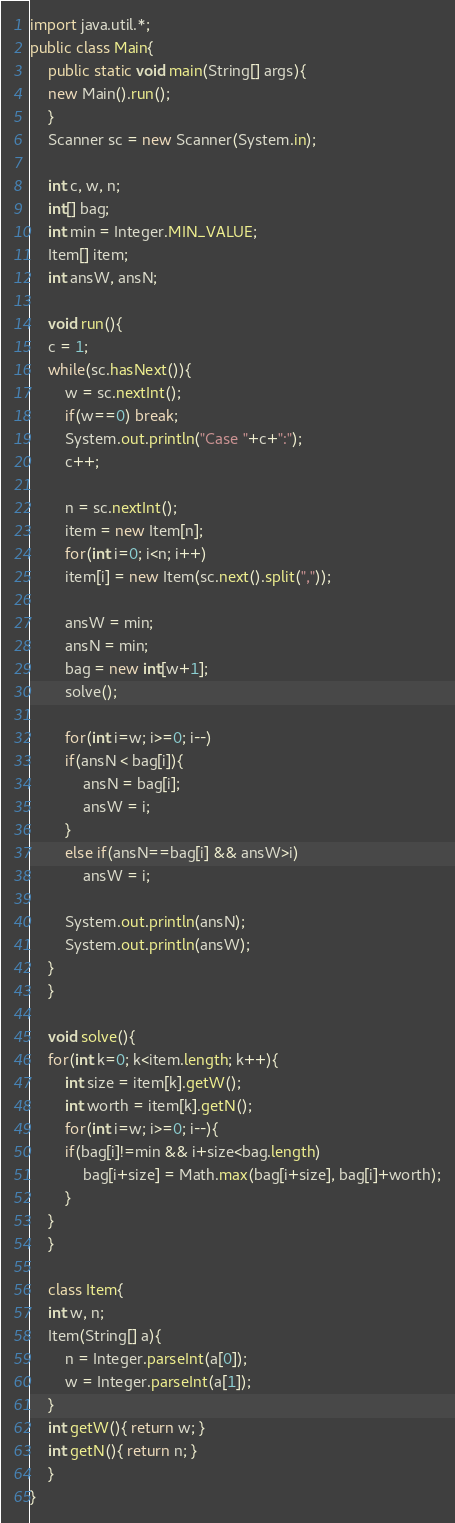<code> <loc_0><loc_0><loc_500><loc_500><_Java_>import java.util.*;
public class Main{
    public static void main(String[] args){
	new Main().run();
    }
    Scanner sc = new Scanner(System.in);

    int c, w, n;
    int[] bag;
    int min = Integer.MIN_VALUE;
    Item[] item;
    int ansW, ansN;

    void run(){
	c = 1;
	while(sc.hasNext()){
	    w = sc.nextInt();
	    if(w==0) break;
	    System.out.println("Case "+c+":");
	    c++;

	    n = sc.nextInt();
	    item = new Item[n];
	    for(int i=0; i<n; i++)
		item[i] = new Item(sc.next().split(","));

	    ansW = min;
	    ansN = min;
	    bag = new int[w+1];
	    solve();

	    for(int i=w; i>=0; i--)
		if(ansN < bag[i]){
		    ansN = bag[i];
		    ansW = i;
		}
		else if(ansN==bag[i] && ansW>i)
		    ansW = i;

	    System.out.println(ansN);
	    System.out.println(ansW);
	}
    }

    void solve(){
	for(int k=0; k<item.length; k++){
	    int size = item[k].getW();
	    int worth = item[k].getN();
	    for(int i=w; i>=0; i--){
		if(bag[i]!=min && i+size<bag.length)
		    bag[i+size] = Math.max(bag[i+size], bag[i]+worth);
	    }
	}
    }

    class Item{
	int w, n;
	Item(String[] a){
	    n = Integer.parseInt(a[0]);
	    w = Integer.parseInt(a[1]);
	}
	int getW(){ return w; }
	int getN(){ return n; }
    }
}</code> 